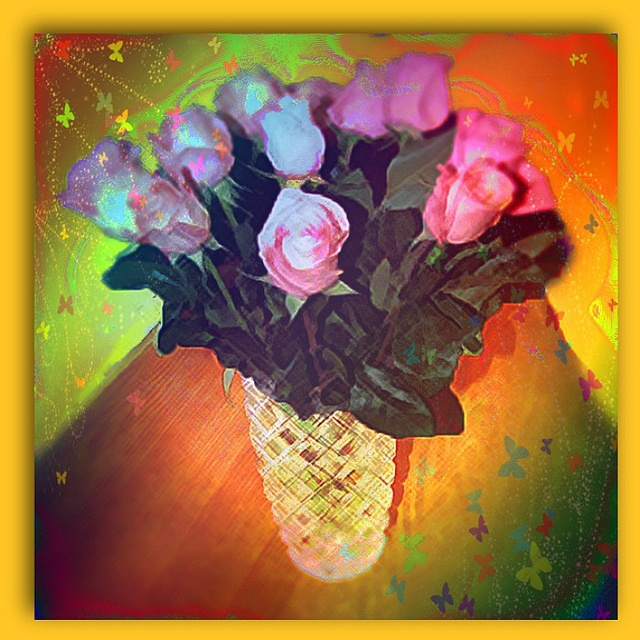Describe the objects in this image and their specific colors. I can see a vase in gold, tan, and khaki tones in this image. 